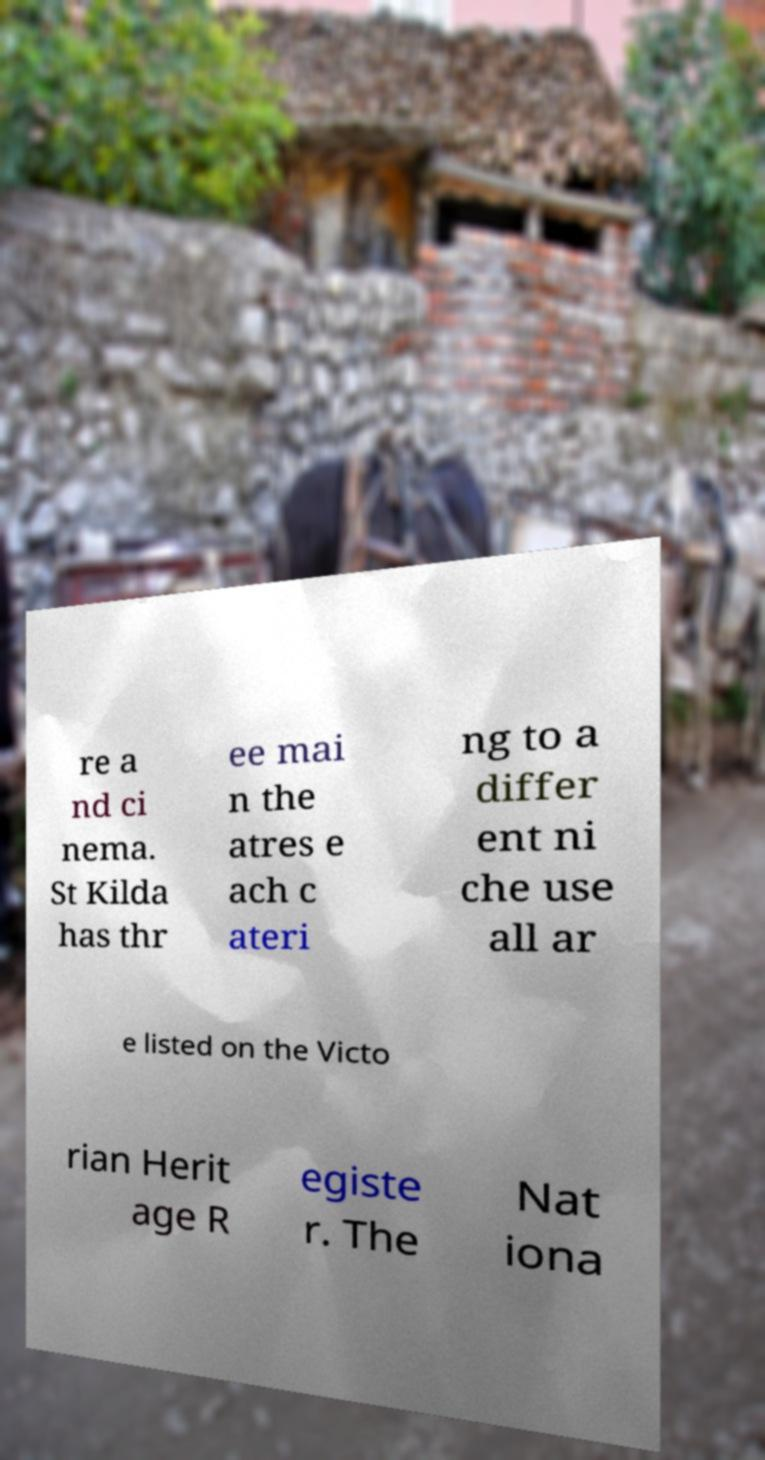Please read and relay the text visible in this image. What does it say? re a nd ci nema. St Kilda has thr ee mai n the atres e ach c ateri ng to a differ ent ni che use all ar e listed on the Victo rian Herit age R egiste r. The Nat iona 